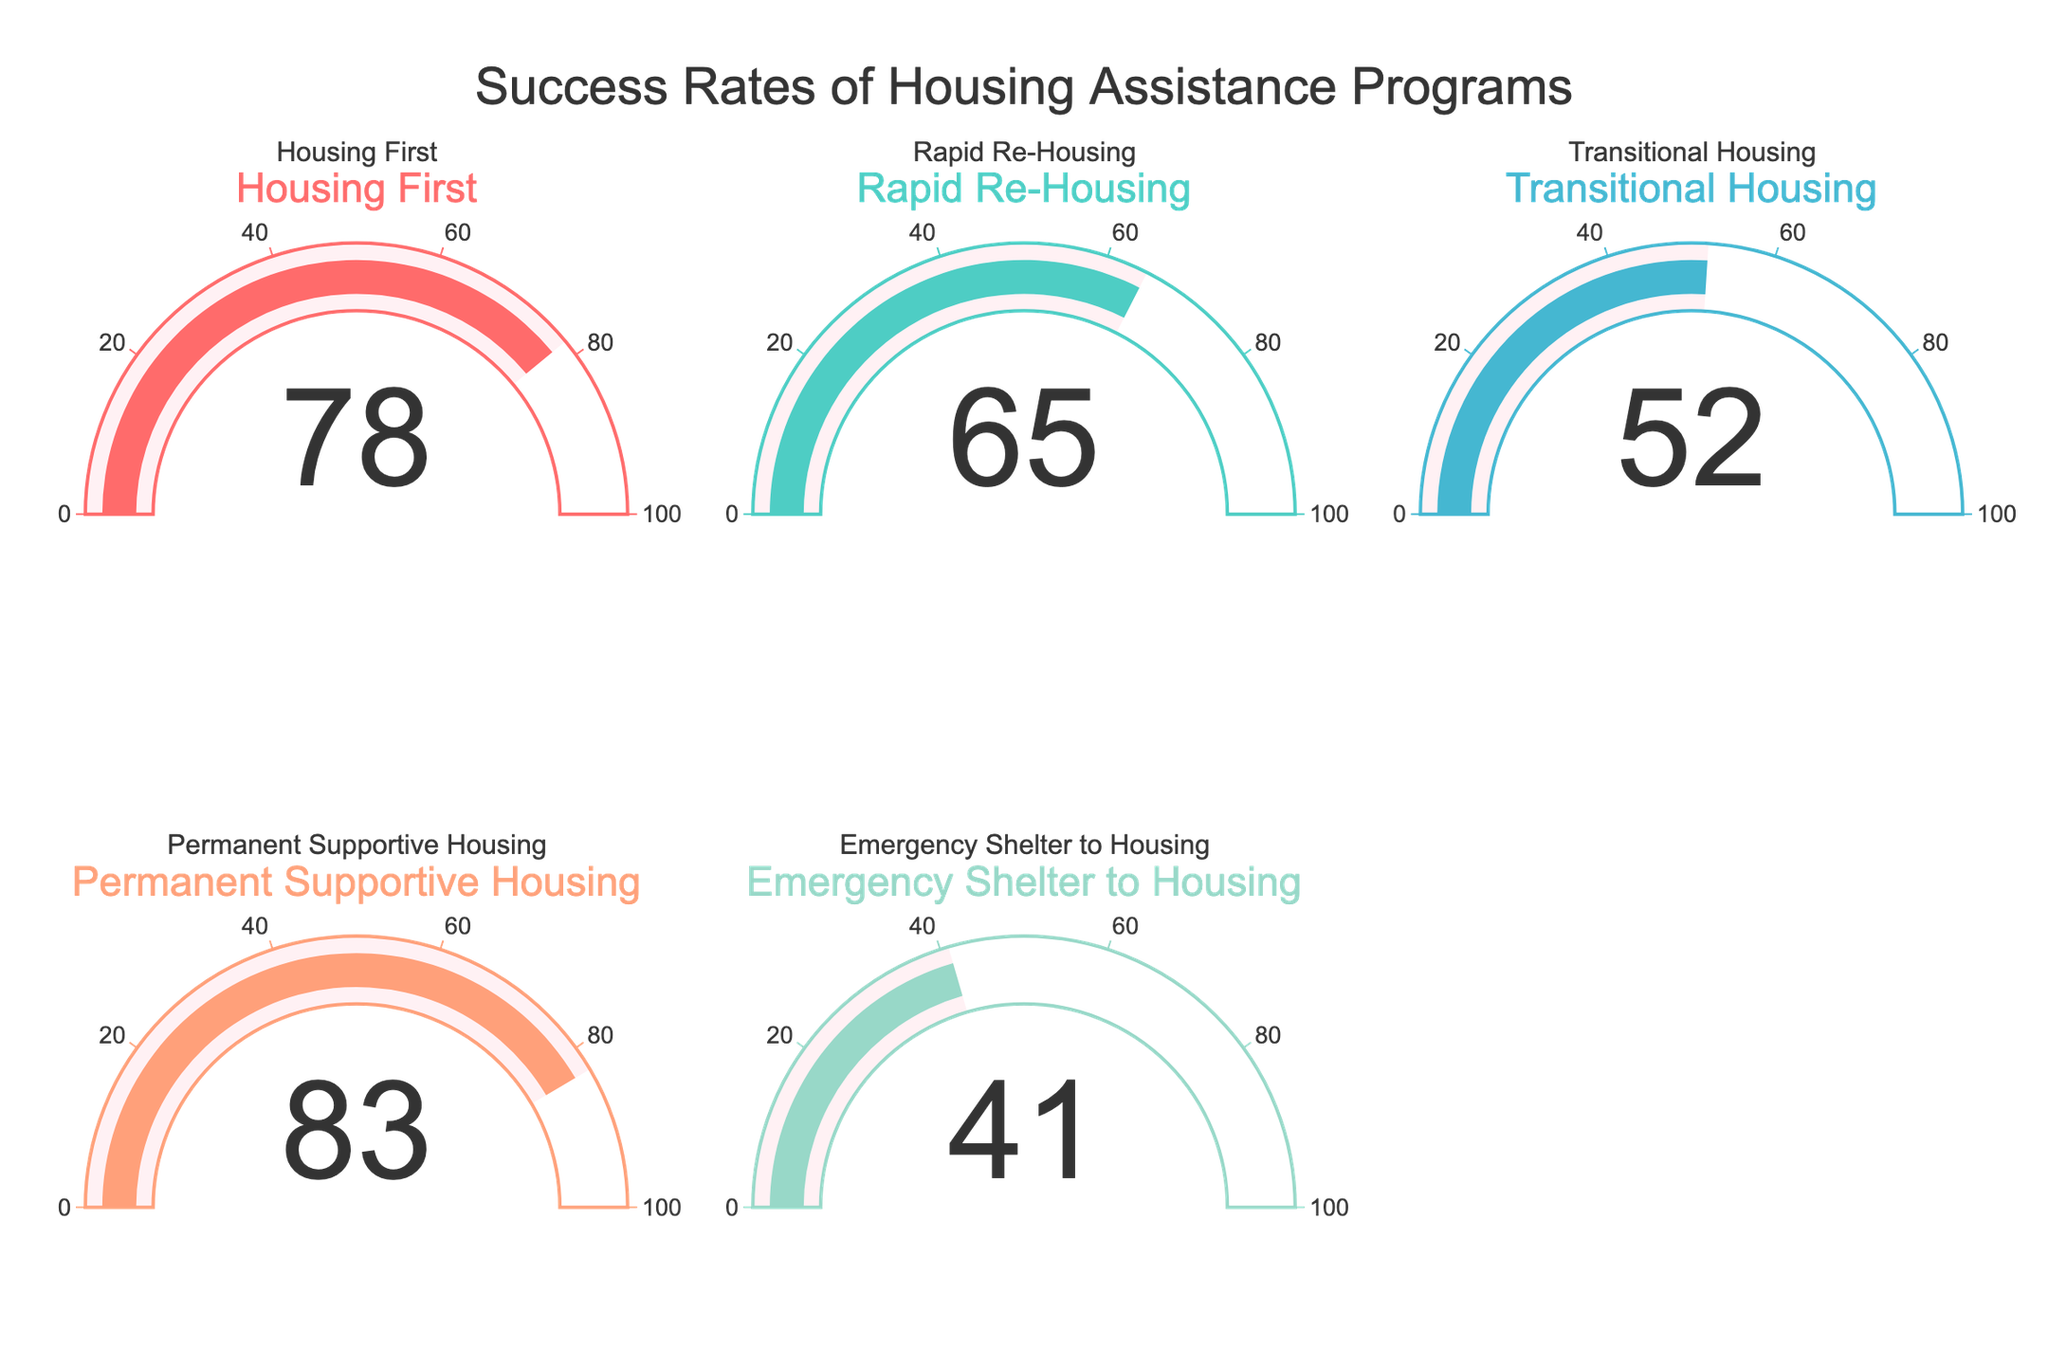What program has the highest success rate? Look at each gauge and identify the highest value. "Permanent Supportive Housing" has the highest success rate of 83%.
Answer: Permanent Supportive Housing Which program has the lowest success rate? Look at each gauge and identify the lowest value. "Emergency Shelter to Housing" has the lowest success rate of 41%.
Answer: Emergency Shelter to Housing What is the average success rate across all programs? Add the success rates of all programs and divide by the number of programs. (78 + 65 + 52 + 83 + 41) / 5 = 63.8%
Answer: 63.8% Between "Rapid Re-Housing" and "Transitional Housing", which has a higher success rate? Compare the success rates of "Rapid Re-Housing" (65%) and "Transitional Housing" (52%). "Rapid Re-Housing" has a higher success rate.
Answer: Rapid Re-Housing What is the difference in success rate between the highest and lowest programs? Subtract the lowest success rate (41% for "Emergency Shelter to Housing") from the highest (83% for "Permanent Supportive Housing"). 83 - 41 = 42%
Answer: 42% How many programs have a success rate higher than 60%? Identify all programs with success rates higher than 60%. "Housing First" (78%), "Rapid Re-Housing" (65%), and "Permanent Supportive Housing" (83%) make 3 programs.
Answer: 3 Which programs have a success rate between 50% and 70%? Identify all programs with success rates within the range 50% to 70%. "Rapid Re-Housing" (65%) and "Transitional Housing" (52%).
Answer: Rapid Re-Housing, Transitional Housing What is the sum of success rates for "Housing First" and "Permanent Supportive Housing"? Add the success rates of "Housing First" (78%) and "Permanent Supportive Housing" (83%). 78 + 83 = 161%
Answer: 161% What is the range of success rates among the programs? Subtract the minimum success rate (41% for "Emergency Shelter to Housing") from the maximum success rate (83% for "Permanent Supportive Housing"). 83 - 41 = 42%
Answer: 42% What is the median success rate of all the programs? Order the success rates and find the middle value. The ordered rates are 41%, 52%, 65%, 78%, 83%. The median value is the middle one, 65%.
Answer: 65% 